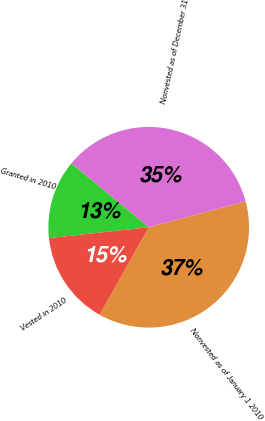<chart> <loc_0><loc_0><loc_500><loc_500><pie_chart><fcel>Nonvested as of January 1 2010<fcel>Nonvested as of December 31<fcel>Granted in 2010<fcel>Vested in 2010<nl><fcel>37.29%<fcel>34.86%<fcel>12.71%<fcel>15.14%<nl></chart> 